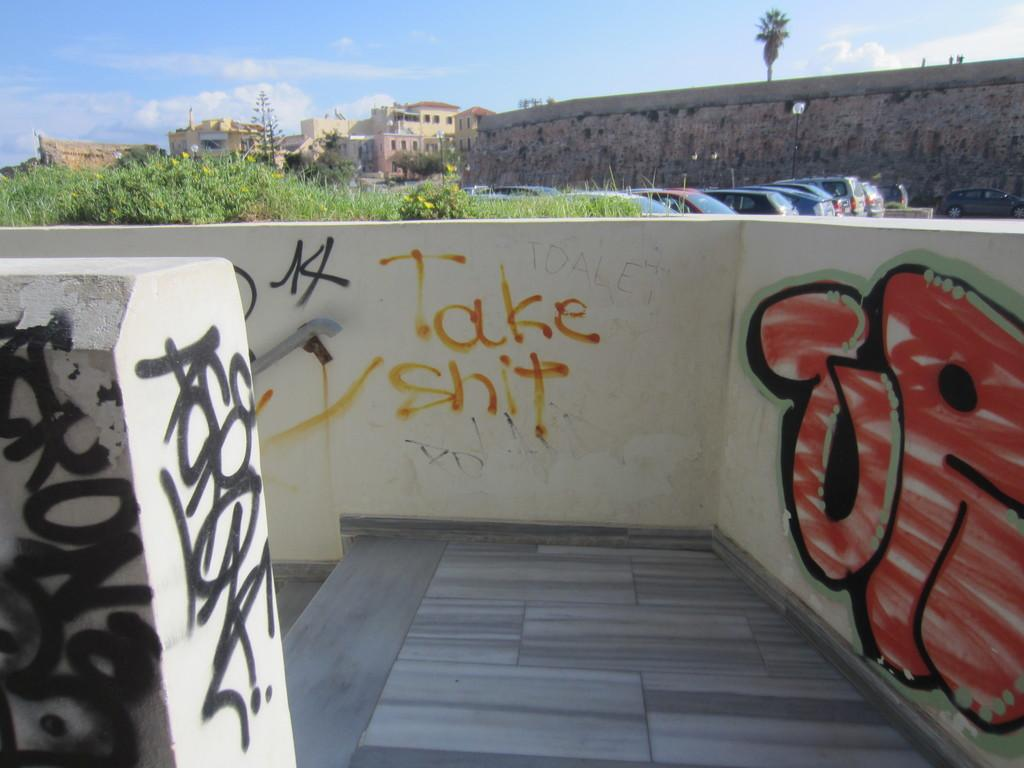What can be seen on the walls in the image? There are texts and drawings on the walls. What is visible on the ground in the image? The floor is visible in the image. What can be seen in the distance in the image? There are trees, vehicles, buildings, windows, and poles in the background of the image. What is visible in the sky in the image? Clouds are visible in the sky. Who is the owner of the match in the image? There is no match present in the image. What type of game is being played in the image? There is no game being played in the image. 